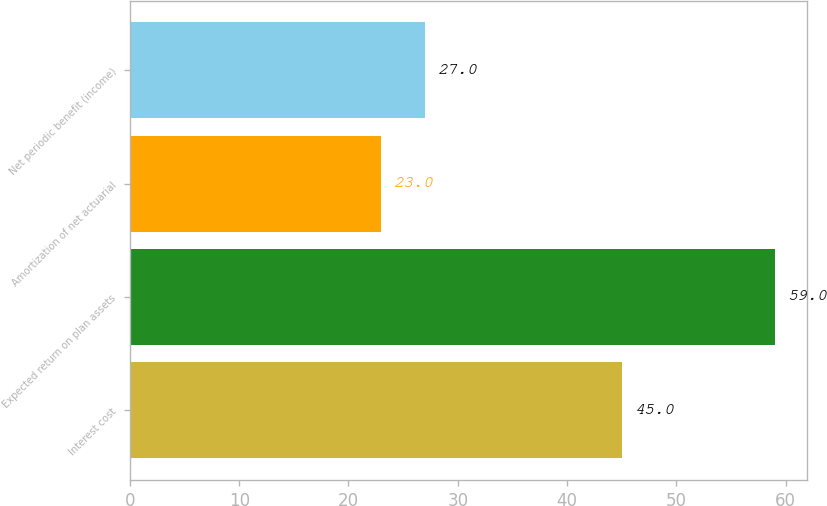Convert chart. <chart><loc_0><loc_0><loc_500><loc_500><bar_chart><fcel>Interest cost<fcel>Expected return on plan assets<fcel>Amortization of net actuarial<fcel>Net periodic benefit (income)<nl><fcel>45<fcel>59<fcel>23<fcel>27<nl></chart> 